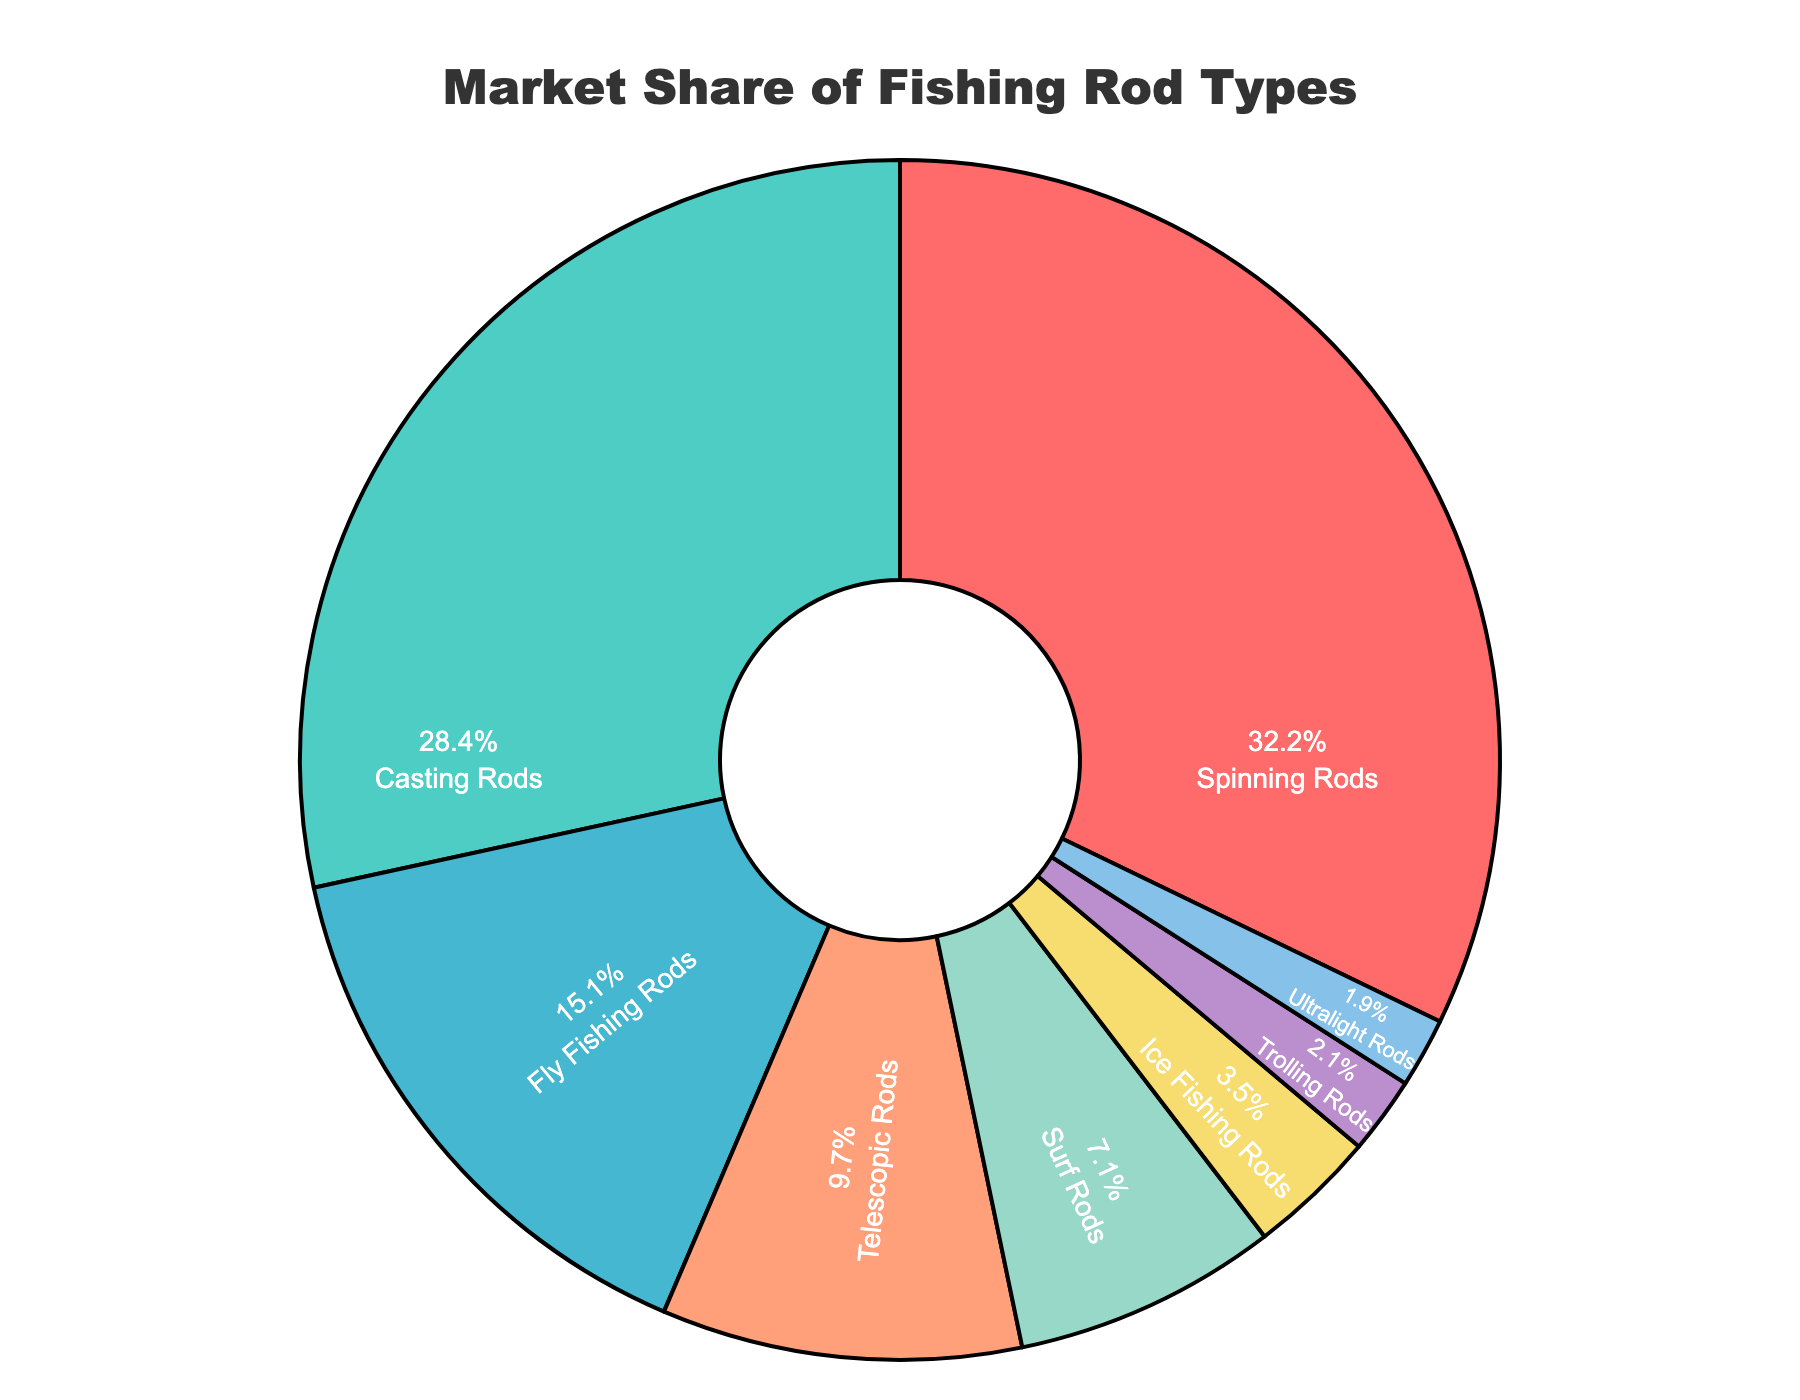What's the most popular fishing rod type based on market share? The pie chart shows market share percentages for each fishing rod type, and the segment labeled "Spinning Rods" has the largest share.
Answer: Spinning Rods Which two rod types together make up more than half of the market share? The shares for Spinning Rods and Casting Rods are 32.5% and 28.7%, respectively. Together, they sum up to 32.5% + 28.7% = 61.2%. This is more than 50%.
Answer: Spinning Rods and Casting Rods How much more market share do Spinning Rods have compared to Ultralight Rods? Spinning Rods have a market share of 32.5%, and Ultralight Rods have 1.9%. The difference is calculated as 32.5% - 1.9% = 30.6%.
Answer: 30.6% What is the combined market share of Surf Rods and Ice Fishing Rods? The market shares are 7.2% for Surf Rods and 3.5% for Ice Fishing Rods. Adding these together gives 7.2% + 3.5% = 10.7%.
Answer: 10.7% Which rod type has the smallest market share and what is its percentage? By observing the pie chart, the smallest segment is labeled "Ultralight Rods" with a market share percentage label of 1.9%.
Answer: Ultralight Rods, 1.9% By what percentage does Fly Fishing Rods' market share exceed Ice Fishing Rods' market share? Fly Fishing Rods have a market share of 15.3%, while Ice Fishing Rods have 3.5%. The percentage difference is calculated as 15.3% - 3.5% = 11.8%.
Answer: 11.8% If Fly Fishing Rods and Trolling Rods are combined, what is their total market share? The pie chart shows Fly Fishing Rods with 15.3% and Trolling Rods with 2.1%. Their combined market share is 15.3% + 2.1% = 17.4%.
Answer: 17.4% Compare the market shares of Casting Rods and Surf Rods. Which one is larger and by how much? Casting Rods have a market share of 28.7%, and Surf Rods have 7.2%. The difference is calculated as 28.7% - 7.2% = 21.5%.
Answer: Casting Rods by 21.5% Which fishing rod type is visualized in blue color and what is its market share percentage? On the pie chart, the blue-colored segment is labeled "Telescopic Rods," which has a market share of 9.8%.
Answer: Telescopic Rods, 9.8% 